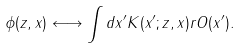Convert formula to latex. <formula><loc_0><loc_0><loc_500><loc_500>\phi ( z , x ) \longleftrightarrow \int d x ^ { \prime } K ( x ^ { \prime } ; z , x ) { r { O } } ( x ^ { \prime } ) .</formula> 